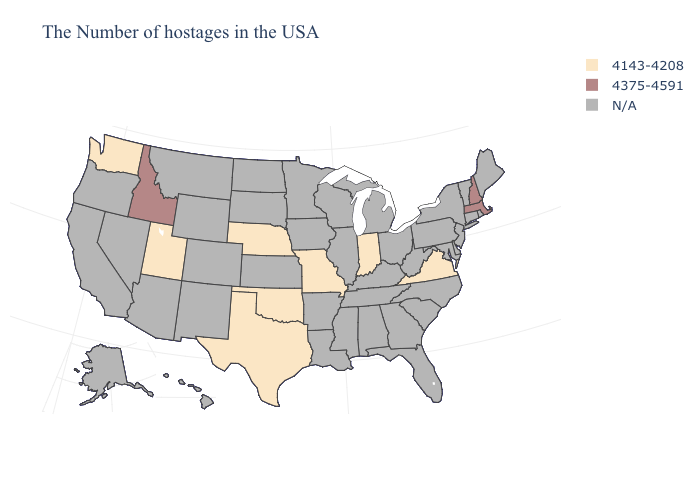Is the legend a continuous bar?
Keep it brief. No. What is the value of Virginia?
Answer briefly. 4143-4208. What is the value of Massachusetts?
Concise answer only. 4375-4591. Does the map have missing data?
Keep it brief. Yes. What is the value of Colorado?
Be succinct. N/A. Name the states that have a value in the range 4375-4591?
Quick response, please. Massachusetts, New Hampshire, Idaho. Which states have the lowest value in the USA?
Be succinct. Virginia, Indiana, Missouri, Nebraska, Oklahoma, Texas, Utah, Washington. What is the value of Maine?
Be succinct. N/A. Does the first symbol in the legend represent the smallest category?
Answer briefly. Yes. Name the states that have a value in the range 4375-4591?
Quick response, please. Massachusetts, New Hampshire, Idaho. Does the first symbol in the legend represent the smallest category?
Write a very short answer. Yes. Name the states that have a value in the range N/A?
Quick response, please. Maine, Rhode Island, Vermont, Connecticut, New York, New Jersey, Delaware, Maryland, Pennsylvania, North Carolina, South Carolina, West Virginia, Ohio, Florida, Georgia, Michigan, Kentucky, Alabama, Tennessee, Wisconsin, Illinois, Mississippi, Louisiana, Arkansas, Minnesota, Iowa, Kansas, South Dakota, North Dakota, Wyoming, Colorado, New Mexico, Montana, Arizona, Nevada, California, Oregon, Alaska, Hawaii. 